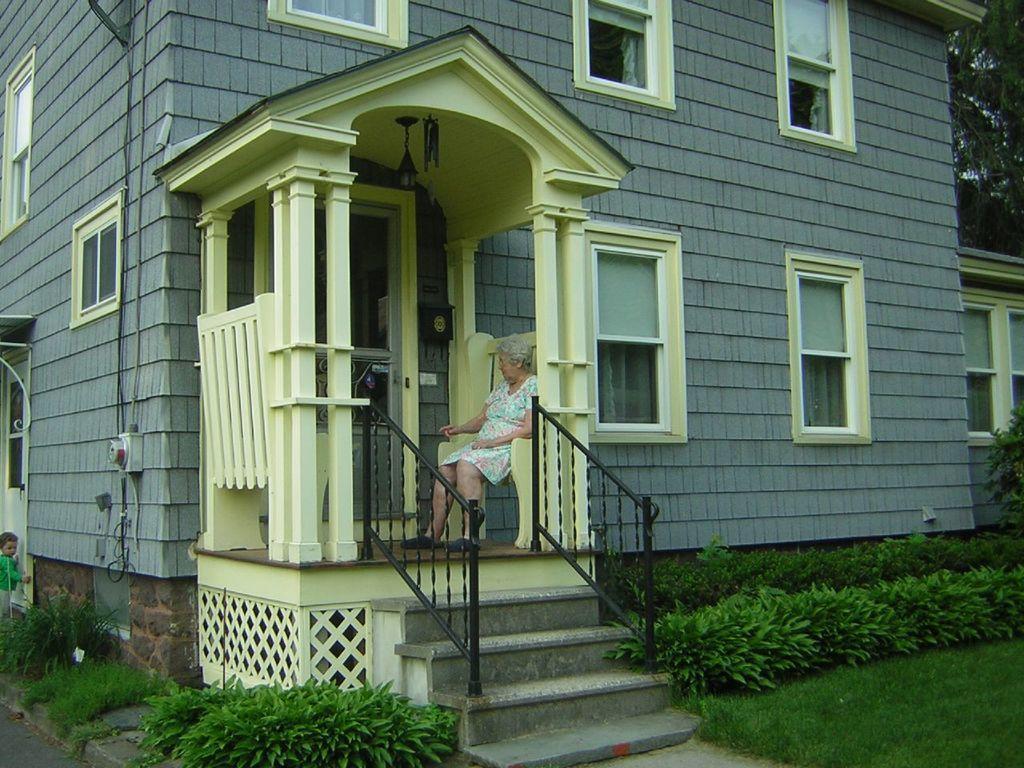Could you give a brief overview of what you see in this image? In this picture we can see a woman is sitting on an object. Behind the woman there is a door and a building. On the right side of the women there are plants, grass and trees. On the left side of the building there is a kid standing on the path. 